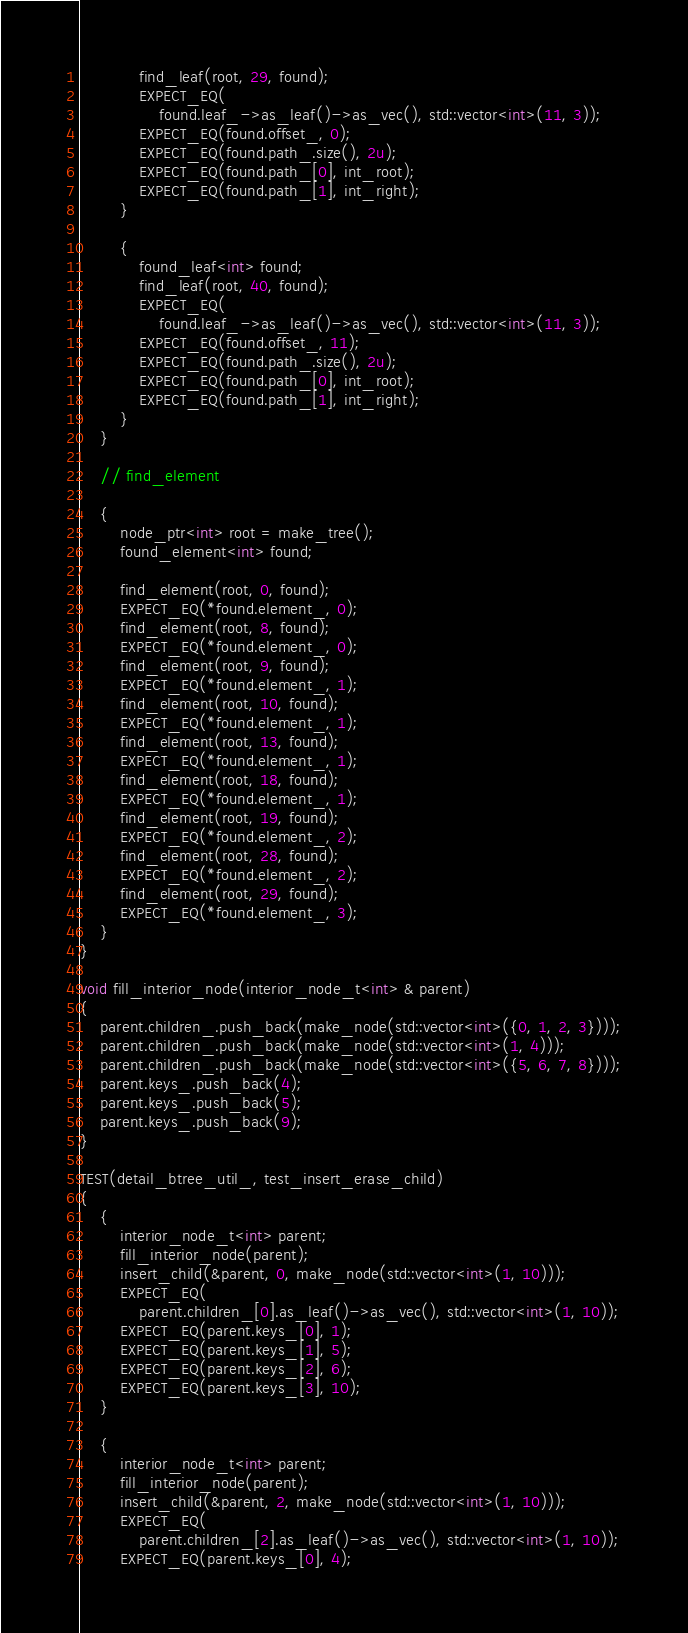<code> <loc_0><loc_0><loc_500><loc_500><_C++_>            find_leaf(root, 29, found);
            EXPECT_EQ(
                found.leaf_->as_leaf()->as_vec(), std::vector<int>(11, 3));
            EXPECT_EQ(found.offset_, 0);
            EXPECT_EQ(found.path_.size(), 2u);
            EXPECT_EQ(found.path_[0], int_root);
            EXPECT_EQ(found.path_[1], int_right);
        }

        {
            found_leaf<int> found;
            find_leaf(root, 40, found);
            EXPECT_EQ(
                found.leaf_->as_leaf()->as_vec(), std::vector<int>(11, 3));
            EXPECT_EQ(found.offset_, 11);
            EXPECT_EQ(found.path_.size(), 2u);
            EXPECT_EQ(found.path_[0], int_root);
            EXPECT_EQ(found.path_[1], int_right);
        }
    }

    // find_element

    {
        node_ptr<int> root = make_tree();
        found_element<int> found;

        find_element(root, 0, found);
        EXPECT_EQ(*found.element_, 0);
        find_element(root, 8, found);
        EXPECT_EQ(*found.element_, 0);
        find_element(root, 9, found);
        EXPECT_EQ(*found.element_, 1);
        find_element(root, 10, found);
        EXPECT_EQ(*found.element_, 1);
        find_element(root, 13, found);
        EXPECT_EQ(*found.element_, 1);
        find_element(root, 18, found);
        EXPECT_EQ(*found.element_, 1);
        find_element(root, 19, found);
        EXPECT_EQ(*found.element_, 2);
        find_element(root, 28, found);
        EXPECT_EQ(*found.element_, 2);
        find_element(root, 29, found);
        EXPECT_EQ(*found.element_, 3);
    }
}

void fill_interior_node(interior_node_t<int> & parent)
{
    parent.children_.push_back(make_node(std::vector<int>({0, 1, 2, 3})));
    parent.children_.push_back(make_node(std::vector<int>(1, 4)));
    parent.children_.push_back(make_node(std::vector<int>({5, 6, 7, 8})));
    parent.keys_.push_back(4);
    parent.keys_.push_back(5);
    parent.keys_.push_back(9);
}

TEST(detail_btree_util_, test_insert_erase_child)
{
    {
        interior_node_t<int> parent;
        fill_interior_node(parent);
        insert_child(&parent, 0, make_node(std::vector<int>(1, 10)));
        EXPECT_EQ(
            parent.children_[0].as_leaf()->as_vec(), std::vector<int>(1, 10));
        EXPECT_EQ(parent.keys_[0], 1);
        EXPECT_EQ(parent.keys_[1], 5);
        EXPECT_EQ(parent.keys_[2], 6);
        EXPECT_EQ(parent.keys_[3], 10);
    }

    {
        interior_node_t<int> parent;
        fill_interior_node(parent);
        insert_child(&parent, 2, make_node(std::vector<int>(1, 10)));
        EXPECT_EQ(
            parent.children_[2].as_leaf()->as_vec(), std::vector<int>(1, 10));
        EXPECT_EQ(parent.keys_[0], 4);</code> 